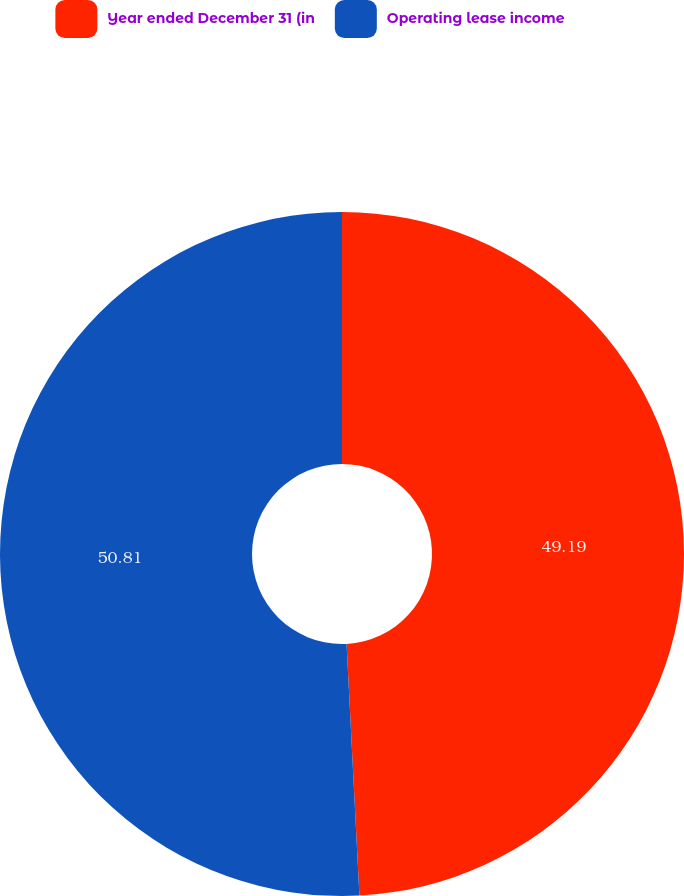Convert chart to OTSL. <chart><loc_0><loc_0><loc_500><loc_500><pie_chart><fcel>Year ended December 31 (in<fcel>Operating lease income<nl><fcel>49.19%<fcel>50.81%<nl></chart> 